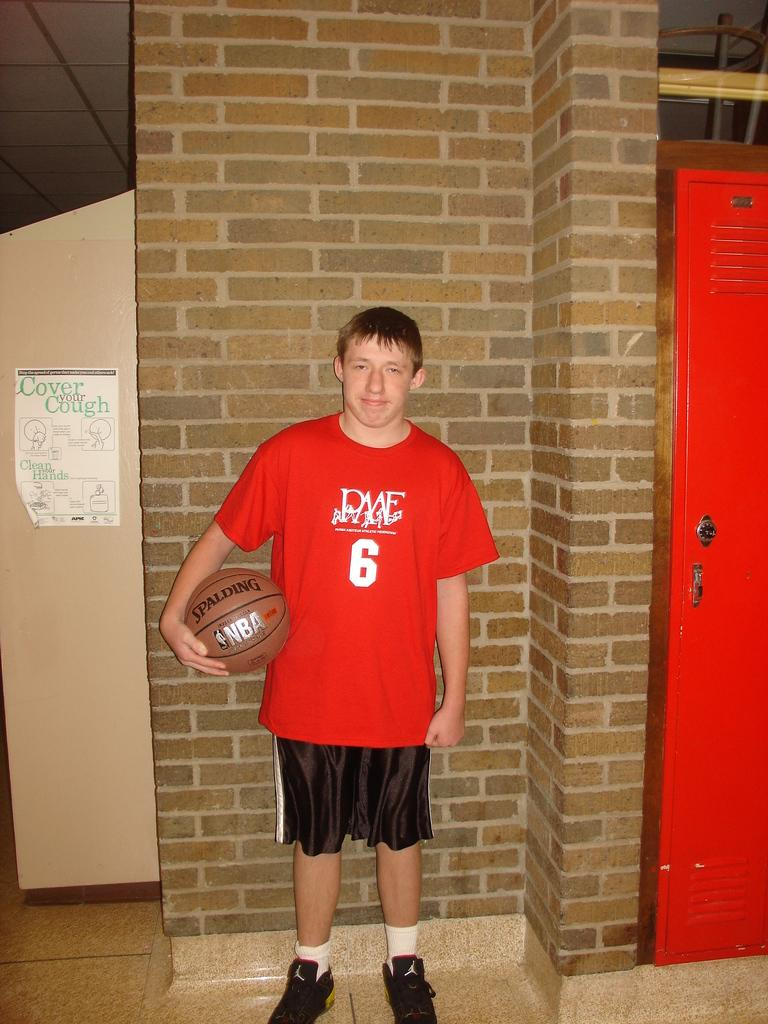<image>
Present a compact description of the photo's key features. A young man in a red shirt that says PAAF 6. 